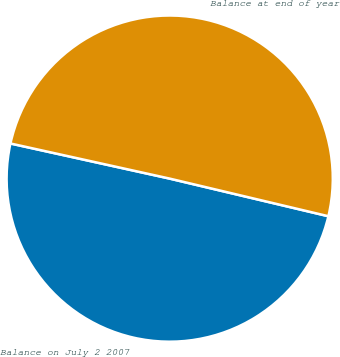<chart> <loc_0><loc_0><loc_500><loc_500><pie_chart><fcel>Balance on July 2 2007<fcel>Balance at end of year<nl><fcel>49.75%<fcel>50.25%<nl></chart> 